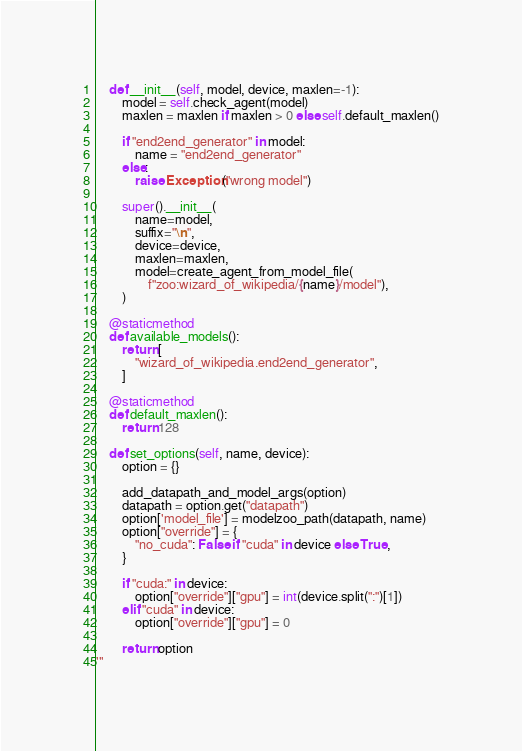<code> <loc_0><loc_0><loc_500><loc_500><_Python_>    def __init__(self, model, device, maxlen=-1):
        model = self.check_agent(model)
        maxlen = maxlen if maxlen > 0 else self.default_maxlen()

        if "end2end_generator" in model:
            name = "end2end_generator"
        else:
            raise Exception("wrong model")

        super().__init__(
            name=model,
            suffix="\n",
            device=device,
            maxlen=maxlen,
            model=create_agent_from_model_file(
                f"zoo:wizard_of_wikipedia/{name}/model"),
        )

    @staticmethod
    def available_models():
        return [
            "wizard_of_wikipedia.end2end_generator",
        ]

    @staticmethod
    def default_maxlen():
        return 128

    def set_options(self, name, device):
        option = {}

        add_datapath_and_model_args(option)
        datapath = option.get("datapath")
        option['model_file'] = modelzoo_path(datapath, name)
        option["override"] = {
            "no_cuda": False if "cuda" in device else True,
        }

        if "cuda:" in device:
            option["override"]["gpu"] = int(device.split(":")[1])
        elif "cuda" in device:
            option["override"]["gpu"] = 0

        return option
'''</code> 